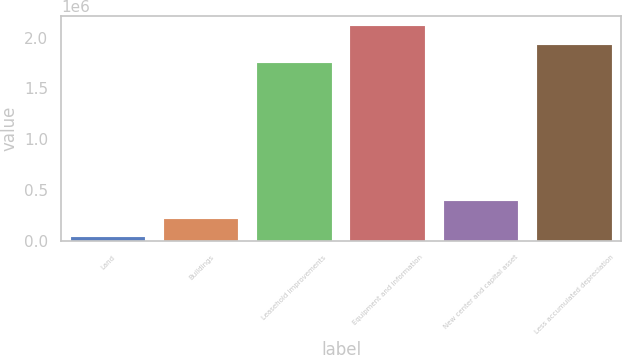Convert chart. <chart><loc_0><loc_0><loc_500><loc_500><bar_chart><fcel>Land<fcel>Buildings<fcel>Leasehold improvements<fcel>Equipment and information<fcel>New center and capital asset<fcel>Less accumulated depreciation<nl><fcel>34960<fcel>214686<fcel>1.74963e+06<fcel>2.10908e+06<fcel>394412<fcel>1.92936e+06<nl></chart> 